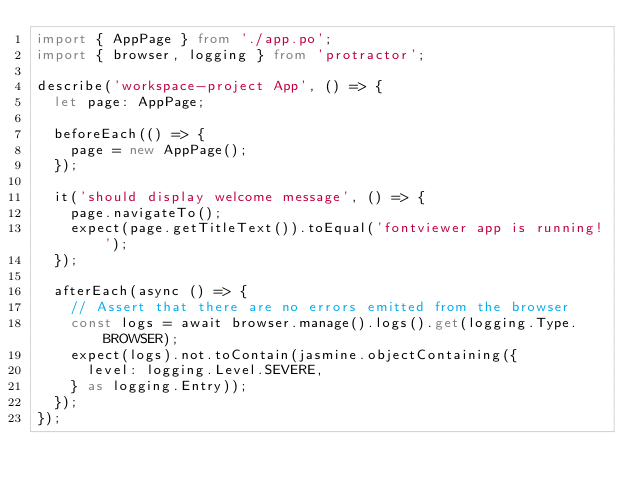Convert code to text. <code><loc_0><loc_0><loc_500><loc_500><_TypeScript_>import { AppPage } from './app.po';
import { browser, logging } from 'protractor';

describe('workspace-project App', () => {
  let page: AppPage;

  beforeEach(() => {
    page = new AppPage();
  });

  it('should display welcome message', () => {
    page.navigateTo();
    expect(page.getTitleText()).toEqual('fontviewer app is running!');
  });

  afterEach(async () => {
    // Assert that there are no errors emitted from the browser
    const logs = await browser.manage().logs().get(logging.Type.BROWSER);
    expect(logs).not.toContain(jasmine.objectContaining({
      level: logging.Level.SEVERE,
    } as logging.Entry));
  });
});
</code> 